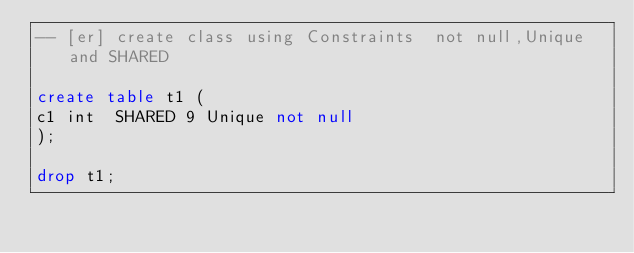Convert code to text. <code><loc_0><loc_0><loc_500><loc_500><_SQL_>-- [er] create class using Constraints  not null,Unique and SHARED

create table t1 (
c1 int  SHARED 9 Unique not null 
);

drop t1;</code> 